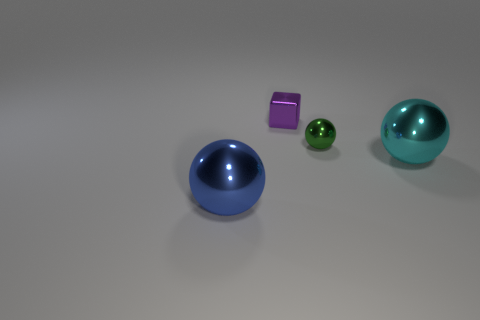The big object left of the big thing to the right of the small purple object is what shape? sphere 